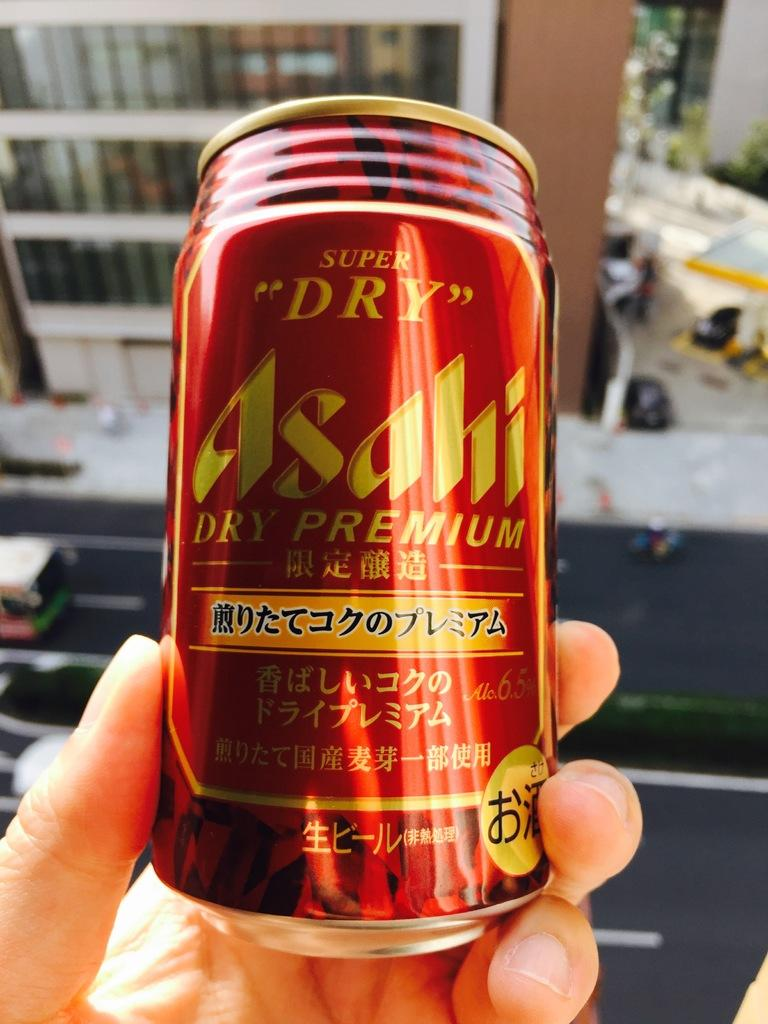<image>
Describe the image concisely. a person is holding a can of Asahi dry premium drink in their hands 